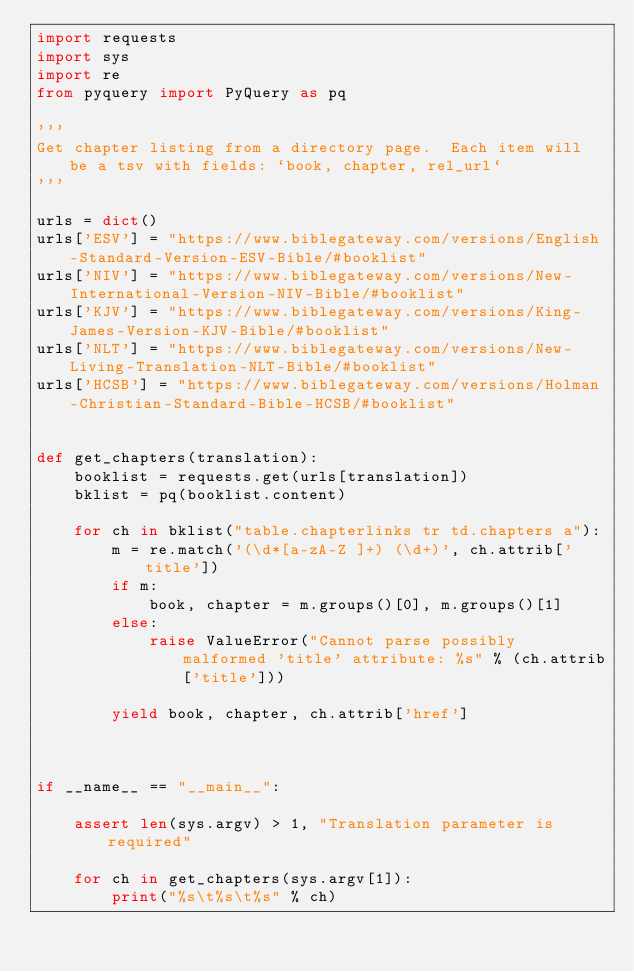<code> <loc_0><loc_0><loc_500><loc_500><_Python_>import requests
import sys
import re
from pyquery import PyQuery as pq

'''
Get chapter listing from a directory page.  Each item will be a tsv with fields: `book, chapter, rel_url`
'''

urls = dict()
urls['ESV'] = "https://www.biblegateway.com/versions/English-Standard-Version-ESV-Bible/#booklist"
urls['NIV'] = "https://www.biblegateway.com/versions/New-International-Version-NIV-Bible/#booklist"
urls['KJV'] = "https://www.biblegateway.com/versions/King-James-Version-KJV-Bible/#booklist"
urls['NLT'] = "https://www.biblegateway.com/versions/New-Living-Translation-NLT-Bible/#booklist"
urls['HCSB'] = "https://www.biblegateway.com/versions/Holman-Christian-Standard-Bible-HCSB/#booklist"


def get_chapters(translation):
    booklist = requests.get(urls[translation])
    bklist = pq(booklist.content)

    for ch in bklist("table.chapterlinks tr td.chapters a"):
        m = re.match('(\d*[a-zA-Z ]+) (\d+)', ch.attrib['title'])
        if m:
            book, chapter = m.groups()[0], m.groups()[1]
        else:
            raise ValueError("Cannot parse possibly malformed 'title' attribute: %s" % (ch.attrib['title']))

        yield book, chapter, ch.attrib['href']



if __name__ == "__main__":

    assert len(sys.argv) > 1, "Translation parameter is required"

    for ch in get_chapters(sys.argv[1]):
        print("%s\t%s\t%s" % ch)
</code> 